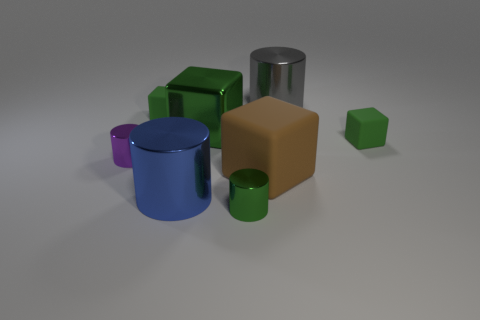Subtract all cyan cylinders. How many green cubes are left? 3 Add 2 small purple shiny things. How many objects exist? 10 Subtract 1 brown blocks. How many objects are left? 7 Subtract all large green blocks. Subtract all small matte cylinders. How many objects are left? 7 Add 6 brown cubes. How many brown cubes are left? 7 Add 3 big cyan matte things. How many big cyan matte things exist? 3 